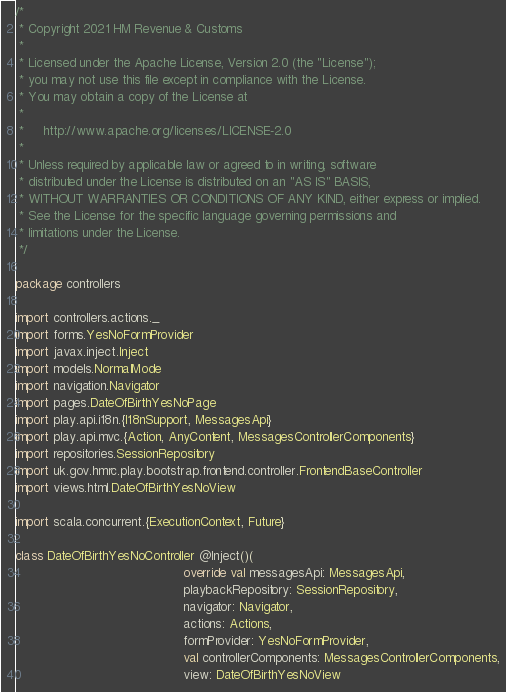Convert code to text. <code><loc_0><loc_0><loc_500><loc_500><_Scala_>/*
 * Copyright 2021 HM Revenue & Customs
 *
 * Licensed under the Apache License, Version 2.0 (the "License");
 * you may not use this file except in compliance with the License.
 * You may obtain a copy of the License at
 *
 *     http://www.apache.org/licenses/LICENSE-2.0
 *
 * Unless required by applicable law or agreed to in writing, software
 * distributed under the License is distributed on an "AS IS" BASIS,
 * WITHOUT WARRANTIES OR CONDITIONS OF ANY KIND, either express or implied.
 * See the License for the specific language governing permissions and
 * limitations under the License.
 */

package controllers

import controllers.actions._
import forms.YesNoFormProvider
import javax.inject.Inject
import models.NormalMode
import navigation.Navigator
import pages.DateOfBirthYesNoPage
import play.api.i18n.{I18nSupport, MessagesApi}
import play.api.mvc.{Action, AnyContent, MessagesControllerComponents}
import repositories.SessionRepository
import uk.gov.hmrc.play.bootstrap.frontend.controller.FrontendBaseController
import views.html.DateOfBirthYesNoView

import scala.concurrent.{ExecutionContext, Future}

class DateOfBirthYesNoController @Inject()(
                                            override val messagesApi: MessagesApi,
                                            playbackRepository: SessionRepository,
                                            navigator: Navigator,
                                            actions: Actions,
                                            formProvider: YesNoFormProvider,
                                            val controllerComponents: MessagesControllerComponents,
                                            view: DateOfBirthYesNoView</code> 